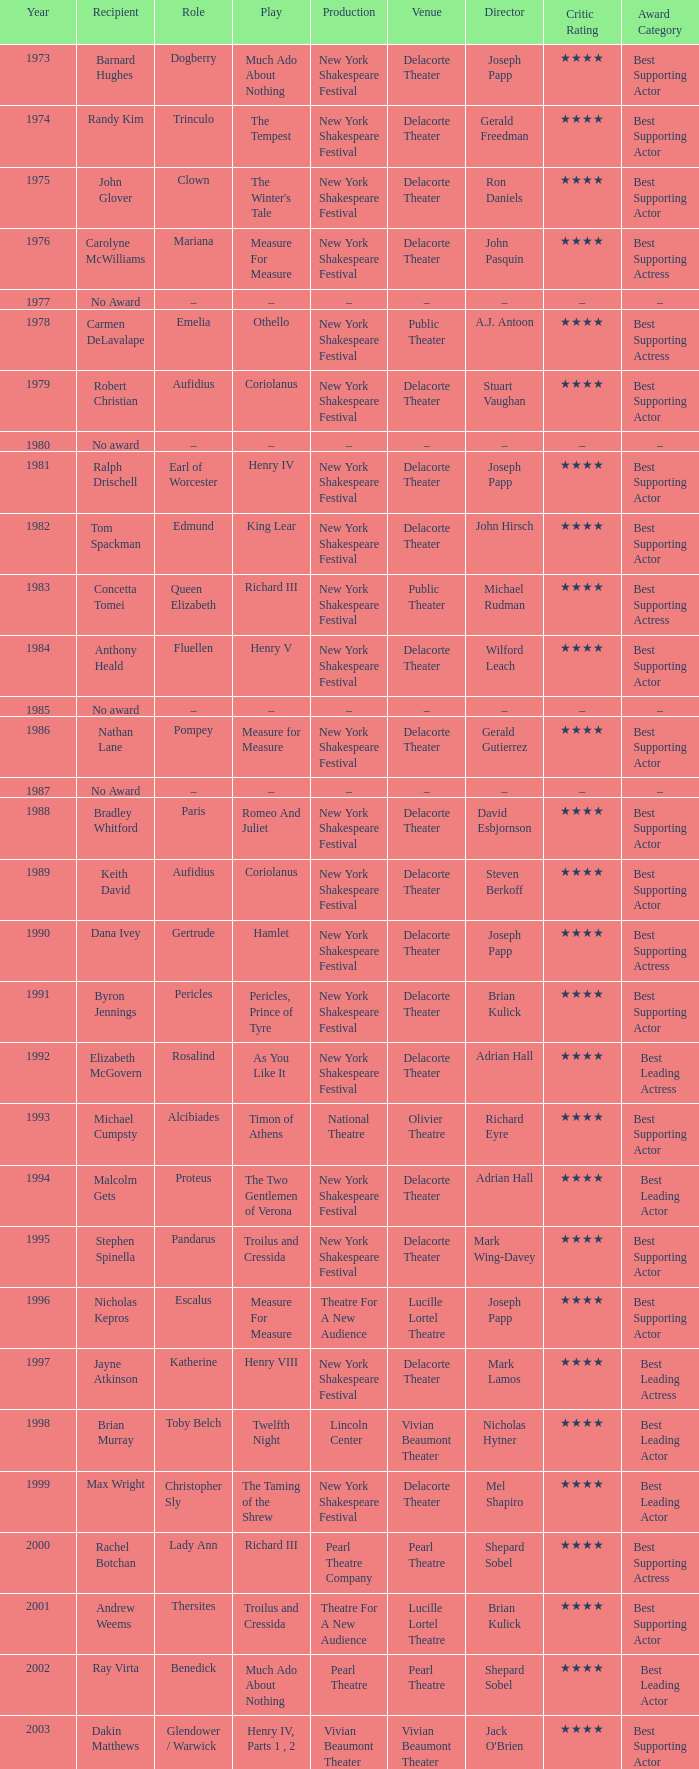Name the recipientof the year for 1976 Carolyne McWilliams. 